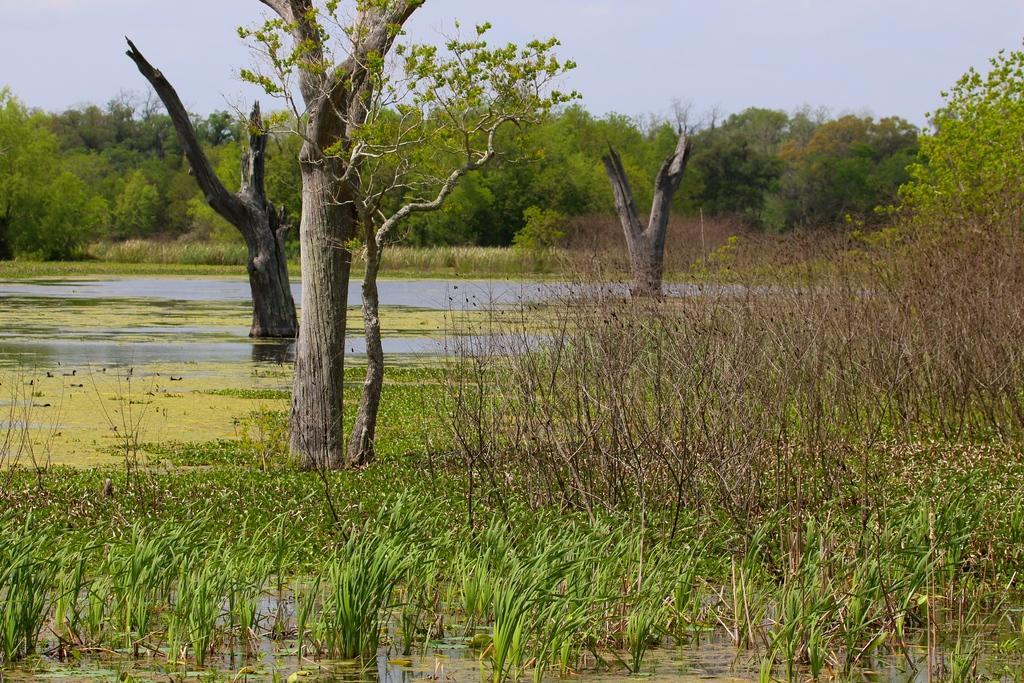How would you summarize this image in a sentence or two? In this image we can see grass, plants and trees are present on the surface of water and the sky is in the background. 